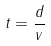Convert formula to latex. <formula><loc_0><loc_0><loc_500><loc_500>t = \frac { d } { v }</formula> 